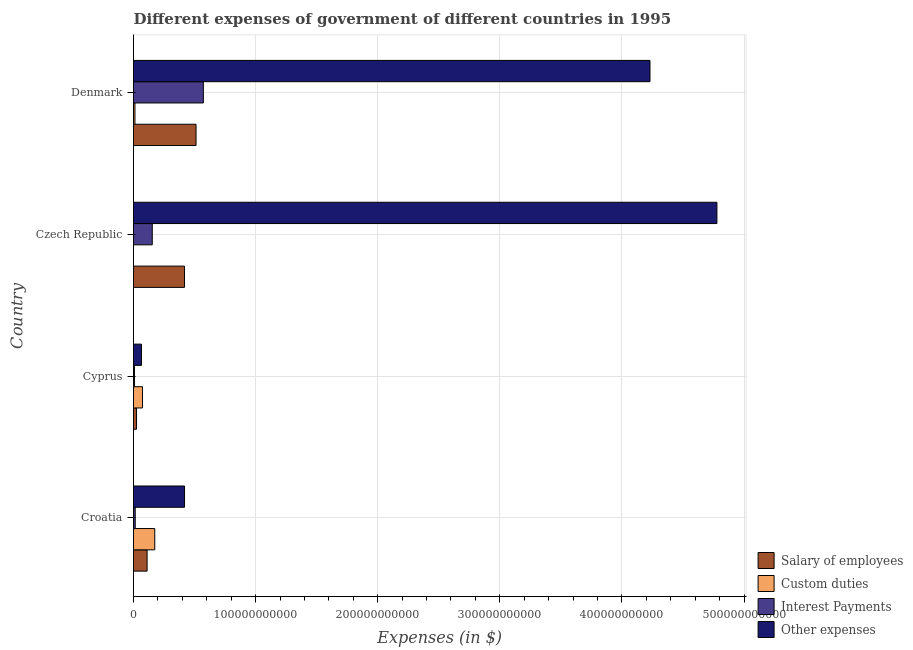How many different coloured bars are there?
Provide a short and direct response. 4. How many groups of bars are there?
Offer a very short reply. 4. Are the number of bars per tick equal to the number of legend labels?
Offer a very short reply. Yes. How many bars are there on the 3rd tick from the bottom?
Your response must be concise. 4. What is the label of the 3rd group of bars from the top?
Provide a short and direct response. Cyprus. What is the amount spent on interest payments in Denmark?
Give a very brief answer. 5.72e+1. Across all countries, what is the maximum amount spent on salary of employees?
Your answer should be compact. 5.12e+1. Across all countries, what is the minimum amount spent on salary of employees?
Make the answer very short. 2.48e+09. In which country was the amount spent on other expenses minimum?
Keep it short and to the point. Cyprus. What is the total amount spent on other expenses in the graph?
Provide a short and direct response. 9.49e+11. What is the difference between the amount spent on custom duties in Croatia and that in Czech Republic?
Give a very brief answer. 1.74e+1. What is the difference between the amount spent on salary of employees in Czech Republic and the amount spent on custom duties in Denmark?
Your answer should be compact. 4.06e+1. What is the average amount spent on custom duties per country?
Give a very brief answer. 6.49e+09. What is the difference between the amount spent on custom duties and amount spent on interest payments in Croatia?
Give a very brief answer. 1.60e+1. What is the ratio of the amount spent on interest payments in Croatia to that in Czech Republic?
Ensure brevity in your answer.  0.09. What is the difference between the highest and the second highest amount spent on interest payments?
Offer a very short reply. 4.18e+1. What is the difference between the highest and the lowest amount spent on custom duties?
Give a very brief answer. 1.74e+1. What does the 3rd bar from the top in Cyprus represents?
Provide a succinct answer. Custom duties. What does the 2nd bar from the bottom in Czech Republic represents?
Provide a short and direct response. Custom duties. How many bars are there?
Make the answer very short. 16. Are all the bars in the graph horizontal?
Provide a short and direct response. Yes. How many countries are there in the graph?
Provide a short and direct response. 4. What is the difference between two consecutive major ticks on the X-axis?
Your response must be concise. 1.00e+11. Are the values on the major ticks of X-axis written in scientific E-notation?
Offer a very short reply. No. Does the graph contain any zero values?
Provide a short and direct response. No. Does the graph contain grids?
Provide a short and direct response. Yes. How are the legend labels stacked?
Make the answer very short. Vertical. What is the title of the graph?
Provide a succinct answer. Different expenses of government of different countries in 1995. Does "Austria" appear as one of the legend labels in the graph?
Ensure brevity in your answer.  No. What is the label or title of the X-axis?
Provide a short and direct response. Expenses (in $). What is the Expenses (in $) of Salary of employees in Croatia?
Your answer should be compact. 1.11e+1. What is the Expenses (in $) in Custom duties in Croatia?
Offer a very short reply. 1.74e+1. What is the Expenses (in $) of Interest Payments in Croatia?
Your answer should be very brief. 1.40e+09. What is the Expenses (in $) of Other expenses in Croatia?
Keep it short and to the point. 4.18e+1. What is the Expenses (in $) of Salary of employees in Cyprus?
Your response must be concise. 2.48e+09. What is the Expenses (in $) of Custom duties in Cyprus?
Your answer should be very brief. 7.35e+09. What is the Expenses (in $) in Interest Payments in Cyprus?
Give a very brief answer. 7.72e+08. What is the Expenses (in $) in Other expenses in Cyprus?
Keep it short and to the point. 6.52e+09. What is the Expenses (in $) of Salary of employees in Czech Republic?
Give a very brief answer. 4.17e+1. What is the Expenses (in $) in Custom duties in Czech Republic?
Provide a short and direct response. 5.00e+05. What is the Expenses (in $) of Interest Payments in Czech Republic?
Provide a succinct answer. 1.54e+1. What is the Expenses (in $) of Other expenses in Czech Republic?
Give a very brief answer. 4.78e+11. What is the Expenses (in $) in Salary of employees in Denmark?
Ensure brevity in your answer.  5.12e+1. What is the Expenses (in $) of Custom duties in Denmark?
Offer a very short reply. 1.18e+09. What is the Expenses (in $) of Interest Payments in Denmark?
Keep it short and to the point. 5.72e+1. What is the Expenses (in $) in Other expenses in Denmark?
Give a very brief answer. 4.23e+11. Across all countries, what is the maximum Expenses (in $) of Salary of employees?
Your answer should be compact. 5.12e+1. Across all countries, what is the maximum Expenses (in $) in Custom duties?
Your answer should be compact. 1.74e+1. Across all countries, what is the maximum Expenses (in $) in Interest Payments?
Your response must be concise. 5.72e+1. Across all countries, what is the maximum Expenses (in $) of Other expenses?
Give a very brief answer. 4.78e+11. Across all countries, what is the minimum Expenses (in $) of Salary of employees?
Offer a very short reply. 2.48e+09. Across all countries, what is the minimum Expenses (in $) in Custom duties?
Offer a very short reply. 5.00e+05. Across all countries, what is the minimum Expenses (in $) in Interest Payments?
Give a very brief answer. 7.72e+08. Across all countries, what is the minimum Expenses (in $) of Other expenses?
Provide a short and direct response. 6.52e+09. What is the total Expenses (in $) of Salary of employees in the graph?
Your answer should be compact. 1.07e+11. What is the total Expenses (in $) of Custom duties in the graph?
Ensure brevity in your answer.  2.59e+1. What is the total Expenses (in $) of Interest Payments in the graph?
Provide a short and direct response. 7.47e+1. What is the total Expenses (in $) in Other expenses in the graph?
Your answer should be compact. 9.49e+11. What is the difference between the Expenses (in $) of Salary of employees in Croatia and that in Cyprus?
Offer a very short reply. 8.64e+09. What is the difference between the Expenses (in $) of Custom duties in Croatia and that in Cyprus?
Your response must be concise. 1.01e+1. What is the difference between the Expenses (in $) in Interest Payments in Croatia and that in Cyprus?
Offer a terse response. 6.28e+08. What is the difference between the Expenses (in $) in Other expenses in Croatia and that in Cyprus?
Keep it short and to the point. 3.53e+1. What is the difference between the Expenses (in $) in Salary of employees in Croatia and that in Czech Republic?
Your answer should be compact. -3.06e+1. What is the difference between the Expenses (in $) in Custom duties in Croatia and that in Czech Republic?
Keep it short and to the point. 1.74e+1. What is the difference between the Expenses (in $) in Interest Payments in Croatia and that in Czech Republic?
Keep it short and to the point. -1.40e+1. What is the difference between the Expenses (in $) in Other expenses in Croatia and that in Czech Republic?
Your answer should be compact. -4.36e+11. What is the difference between the Expenses (in $) in Salary of employees in Croatia and that in Denmark?
Make the answer very short. -4.01e+1. What is the difference between the Expenses (in $) of Custom duties in Croatia and that in Denmark?
Your response must be concise. 1.62e+1. What is the difference between the Expenses (in $) of Interest Payments in Croatia and that in Denmark?
Your response must be concise. -5.58e+1. What is the difference between the Expenses (in $) of Other expenses in Croatia and that in Denmark?
Your answer should be compact. -3.81e+11. What is the difference between the Expenses (in $) in Salary of employees in Cyprus and that in Czech Republic?
Offer a terse response. -3.93e+1. What is the difference between the Expenses (in $) in Custom duties in Cyprus and that in Czech Republic?
Give a very brief answer. 7.35e+09. What is the difference between the Expenses (in $) in Interest Payments in Cyprus and that in Czech Republic?
Offer a very short reply. -1.46e+1. What is the difference between the Expenses (in $) of Other expenses in Cyprus and that in Czech Republic?
Give a very brief answer. -4.71e+11. What is the difference between the Expenses (in $) in Salary of employees in Cyprus and that in Denmark?
Provide a succinct answer. -4.87e+1. What is the difference between the Expenses (in $) in Custom duties in Cyprus and that in Denmark?
Your answer should be very brief. 6.17e+09. What is the difference between the Expenses (in $) in Interest Payments in Cyprus and that in Denmark?
Provide a short and direct response. -5.64e+1. What is the difference between the Expenses (in $) in Other expenses in Cyprus and that in Denmark?
Your answer should be compact. -4.16e+11. What is the difference between the Expenses (in $) of Salary of employees in Czech Republic and that in Denmark?
Provide a short and direct response. -9.46e+09. What is the difference between the Expenses (in $) in Custom duties in Czech Republic and that in Denmark?
Your response must be concise. -1.18e+09. What is the difference between the Expenses (in $) of Interest Payments in Czech Republic and that in Denmark?
Provide a short and direct response. -4.18e+1. What is the difference between the Expenses (in $) of Other expenses in Czech Republic and that in Denmark?
Give a very brief answer. 5.48e+1. What is the difference between the Expenses (in $) in Salary of employees in Croatia and the Expenses (in $) in Custom duties in Cyprus?
Ensure brevity in your answer.  3.77e+09. What is the difference between the Expenses (in $) in Salary of employees in Croatia and the Expenses (in $) in Interest Payments in Cyprus?
Provide a short and direct response. 1.03e+1. What is the difference between the Expenses (in $) of Salary of employees in Croatia and the Expenses (in $) of Other expenses in Cyprus?
Your response must be concise. 4.60e+09. What is the difference between the Expenses (in $) of Custom duties in Croatia and the Expenses (in $) of Interest Payments in Cyprus?
Your answer should be compact. 1.66e+1. What is the difference between the Expenses (in $) in Custom duties in Croatia and the Expenses (in $) in Other expenses in Cyprus?
Keep it short and to the point. 1.09e+1. What is the difference between the Expenses (in $) of Interest Payments in Croatia and the Expenses (in $) of Other expenses in Cyprus?
Provide a short and direct response. -5.12e+09. What is the difference between the Expenses (in $) of Salary of employees in Croatia and the Expenses (in $) of Custom duties in Czech Republic?
Ensure brevity in your answer.  1.11e+1. What is the difference between the Expenses (in $) of Salary of employees in Croatia and the Expenses (in $) of Interest Payments in Czech Republic?
Keep it short and to the point. -4.24e+09. What is the difference between the Expenses (in $) of Salary of employees in Croatia and the Expenses (in $) of Other expenses in Czech Republic?
Your answer should be compact. -4.67e+11. What is the difference between the Expenses (in $) of Custom duties in Croatia and the Expenses (in $) of Interest Payments in Czech Republic?
Your answer should be very brief. 2.04e+09. What is the difference between the Expenses (in $) in Custom duties in Croatia and the Expenses (in $) in Other expenses in Czech Republic?
Your answer should be very brief. -4.60e+11. What is the difference between the Expenses (in $) of Interest Payments in Croatia and the Expenses (in $) of Other expenses in Czech Republic?
Keep it short and to the point. -4.76e+11. What is the difference between the Expenses (in $) in Salary of employees in Croatia and the Expenses (in $) in Custom duties in Denmark?
Provide a succinct answer. 9.94e+09. What is the difference between the Expenses (in $) of Salary of employees in Croatia and the Expenses (in $) of Interest Payments in Denmark?
Offer a terse response. -4.61e+1. What is the difference between the Expenses (in $) in Salary of employees in Croatia and the Expenses (in $) in Other expenses in Denmark?
Provide a short and direct response. -4.12e+11. What is the difference between the Expenses (in $) in Custom duties in Croatia and the Expenses (in $) in Interest Payments in Denmark?
Your answer should be very brief. -3.98e+1. What is the difference between the Expenses (in $) in Custom duties in Croatia and the Expenses (in $) in Other expenses in Denmark?
Make the answer very short. -4.06e+11. What is the difference between the Expenses (in $) in Interest Payments in Croatia and the Expenses (in $) in Other expenses in Denmark?
Your response must be concise. -4.22e+11. What is the difference between the Expenses (in $) in Salary of employees in Cyprus and the Expenses (in $) in Custom duties in Czech Republic?
Offer a terse response. 2.48e+09. What is the difference between the Expenses (in $) of Salary of employees in Cyprus and the Expenses (in $) of Interest Payments in Czech Republic?
Provide a short and direct response. -1.29e+1. What is the difference between the Expenses (in $) in Salary of employees in Cyprus and the Expenses (in $) in Other expenses in Czech Republic?
Ensure brevity in your answer.  -4.75e+11. What is the difference between the Expenses (in $) of Custom duties in Cyprus and the Expenses (in $) of Interest Payments in Czech Republic?
Make the answer very short. -8.01e+09. What is the difference between the Expenses (in $) of Custom duties in Cyprus and the Expenses (in $) of Other expenses in Czech Republic?
Your answer should be very brief. -4.70e+11. What is the difference between the Expenses (in $) of Interest Payments in Cyprus and the Expenses (in $) of Other expenses in Czech Republic?
Provide a short and direct response. -4.77e+11. What is the difference between the Expenses (in $) in Salary of employees in Cyprus and the Expenses (in $) in Custom duties in Denmark?
Your response must be concise. 1.30e+09. What is the difference between the Expenses (in $) in Salary of employees in Cyprus and the Expenses (in $) in Interest Payments in Denmark?
Your answer should be compact. -5.47e+1. What is the difference between the Expenses (in $) in Salary of employees in Cyprus and the Expenses (in $) in Other expenses in Denmark?
Your response must be concise. -4.20e+11. What is the difference between the Expenses (in $) of Custom duties in Cyprus and the Expenses (in $) of Interest Payments in Denmark?
Make the answer very short. -4.98e+1. What is the difference between the Expenses (in $) of Custom duties in Cyprus and the Expenses (in $) of Other expenses in Denmark?
Provide a short and direct response. -4.16e+11. What is the difference between the Expenses (in $) of Interest Payments in Cyprus and the Expenses (in $) of Other expenses in Denmark?
Your answer should be very brief. -4.22e+11. What is the difference between the Expenses (in $) in Salary of employees in Czech Republic and the Expenses (in $) in Custom duties in Denmark?
Provide a succinct answer. 4.06e+1. What is the difference between the Expenses (in $) in Salary of employees in Czech Republic and the Expenses (in $) in Interest Payments in Denmark?
Give a very brief answer. -1.55e+1. What is the difference between the Expenses (in $) of Salary of employees in Czech Republic and the Expenses (in $) of Other expenses in Denmark?
Your answer should be very brief. -3.81e+11. What is the difference between the Expenses (in $) of Custom duties in Czech Republic and the Expenses (in $) of Interest Payments in Denmark?
Give a very brief answer. -5.72e+1. What is the difference between the Expenses (in $) of Custom duties in Czech Republic and the Expenses (in $) of Other expenses in Denmark?
Your answer should be compact. -4.23e+11. What is the difference between the Expenses (in $) of Interest Payments in Czech Republic and the Expenses (in $) of Other expenses in Denmark?
Your response must be concise. -4.08e+11. What is the average Expenses (in $) of Salary of employees per country?
Provide a succinct answer. 2.66e+1. What is the average Expenses (in $) in Custom duties per country?
Offer a very short reply. 6.49e+09. What is the average Expenses (in $) of Interest Payments per country?
Ensure brevity in your answer.  1.87e+1. What is the average Expenses (in $) in Other expenses per country?
Ensure brevity in your answer.  2.37e+11. What is the difference between the Expenses (in $) of Salary of employees and Expenses (in $) of Custom duties in Croatia?
Offer a very short reply. -6.29e+09. What is the difference between the Expenses (in $) in Salary of employees and Expenses (in $) in Interest Payments in Croatia?
Offer a very short reply. 9.72e+09. What is the difference between the Expenses (in $) in Salary of employees and Expenses (in $) in Other expenses in Croatia?
Offer a very short reply. -3.07e+1. What is the difference between the Expenses (in $) of Custom duties and Expenses (in $) of Interest Payments in Croatia?
Your response must be concise. 1.60e+1. What is the difference between the Expenses (in $) in Custom duties and Expenses (in $) in Other expenses in Croatia?
Ensure brevity in your answer.  -2.44e+1. What is the difference between the Expenses (in $) of Interest Payments and Expenses (in $) of Other expenses in Croatia?
Keep it short and to the point. -4.04e+1. What is the difference between the Expenses (in $) in Salary of employees and Expenses (in $) in Custom duties in Cyprus?
Provide a short and direct response. -4.87e+09. What is the difference between the Expenses (in $) of Salary of employees and Expenses (in $) of Interest Payments in Cyprus?
Give a very brief answer. 1.71e+09. What is the difference between the Expenses (in $) of Salary of employees and Expenses (in $) of Other expenses in Cyprus?
Your response must be concise. -4.04e+09. What is the difference between the Expenses (in $) in Custom duties and Expenses (in $) in Interest Payments in Cyprus?
Make the answer very short. 6.58e+09. What is the difference between the Expenses (in $) in Custom duties and Expenses (in $) in Other expenses in Cyprus?
Provide a succinct answer. 8.31e+08. What is the difference between the Expenses (in $) of Interest Payments and Expenses (in $) of Other expenses in Cyprus?
Provide a succinct answer. -5.75e+09. What is the difference between the Expenses (in $) in Salary of employees and Expenses (in $) in Custom duties in Czech Republic?
Your answer should be very brief. 4.17e+1. What is the difference between the Expenses (in $) of Salary of employees and Expenses (in $) of Interest Payments in Czech Republic?
Provide a short and direct response. 2.64e+1. What is the difference between the Expenses (in $) of Salary of employees and Expenses (in $) of Other expenses in Czech Republic?
Ensure brevity in your answer.  -4.36e+11. What is the difference between the Expenses (in $) in Custom duties and Expenses (in $) in Interest Payments in Czech Republic?
Keep it short and to the point. -1.54e+1. What is the difference between the Expenses (in $) of Custom duties and Expenses (in $) of Other expenses in Czech Republic?
Give a very brief answer. -4.78e+11. What is the difference between the Expenses (in $) of Interest Payments and Expenses (in $) of Other expenses in Czech Republic?
Your answer should be very brief. -4.62e+11. What is the difference between the Expenses (in $) of Salary of employees and Expenses (in $) of Custom duties in Denmark?
Provide a succinct answer. 5.00e+1. What is the difference between the Expenses (in $) of Salary of employees and Expenses (in $) of Interest Payments in Denmark?
Keep it short and to the point. -5.99e+09. What is the difference between the Expenses (in $) in Salary of employees and Expenses (in $) in Other expenses in Denmark?
Your answer should be very brief. -3.72e+11. What is the difference between the Expenses (in $) of Custom duties and Expenses (in $) of Interest Payments in Denmark?
Give a very brief answer. -5.60e+1. What is the difference between the Expenses (in $) of Custom duties and Expenses (in $) of Other expenses in Denmark?
Your answer should be compact. -4.22e+11. What is the difference between the Expenses (in $) of Interest Payments and Expenses (in $) of Other expenses in Denmark?
Your answer should be compact. -3.66e+11. What is the ratio of the Expenses (in $) in Salary of employees in Croatia to that in Cyprus?
Your response must be concise. 4.48. What is the ratio of the Expenses (in $) of Custom duties in Croatia to that in Cyprus?
Ensure brevity in your answer.  2.37. What is the ratio of the Expenses (in $) of Interest Payments in Croatia to that in Cyprus?
Your answer should be very brief. 1.81. What is the ratio of the Expenses (in $) in Other expenses in Croatia to that in Cyprus?
Your answer should be compact. 6.41. What is the ratio of the Expenses (in $) in Salary of employees in Croatia to that in Czech Republic?
Make the answer very short. 0.27. What is the ratio of the Expenses (in $) of Custom duties in Croatia to that in Czech Republic?
Provide a short and direct response. 3.48e+04. What is the ratio of the Expenses (in $) of Interest Payments in Croatia to that in Czech Republic?
Your answer should be compact. 0.09. What is the ratio of the Expenses (in $) in Other expenses in Croatia to that in Czech Republic?
Your response must be concise. 0.09. What is the ratio of the Expenses (in $) in Salary of employees in Croatia to that in Denmark?
Ensure brevity in your answer.  0.22. What is the ratio of the Expenses (in $) in Custom duties in Croatia to that in Denmark?
Offer a very short reply. 14.76. What is the ratio of the Expenses (in $) in Interest Payments in Croatia to that in Denmark?
Offer a terse response. 0.02. What is the ratio of the Expenses (in $) of Other expenses in Croatia to that in Denmark?
Ensure brevity in your answer.  0.1. What is the ratio of the Expenses (in $) in Salary of employees in Cyprus to that in Czech Republic?
Ensure brevity in your answer.  0.06. What is the ratio of the Expenses (in $) in Custom duties in Cyprus to that in Czech Republic?
Give a very brief answer. 1.47e+04. What is the ratio of the Expenses (in $) of Interest Payments in Cyprus to that in Czech Republic?
Give a very brief answer. 0.05. What is the ratio of the Expenses (in $) of Other expenses in Cyprus to that in Czech Republic?
Your answer should be compact. 0.01. What is the ratio of the Expenses (in $) of Salary of employees in Cyprus to that in Denmark?
Your answer should be compact. 0.05. What is the ratio of the Expenses (in $) in Custom duties in Cyprus to that in Denmark?
Your answer should be compact. 6.23. What is the ratio of the Expenses (in $) in Interest Payments in Cyprus to that in Denmark?
Keep it short and to the point. 0.01. What is the ratio of the Expenses (in $) of Other expenses in Cyprus to that in Denmark?
Provide a succinct answer. 0.02. What is the ratio of the Expenses (in $) in Salary of employees in Czech Republic to that in Denmark?
Your answer should be compact. 0.82. What is the ratio of the Expenses (in $) of Interest Payments in Czech Republic to that in Denmark?
Offer a terse response. 0.27. What is the ratio of the Expenses (in $) of Other expenses in Czech Republic to that in Denmark?
Your answer should be very brief. 1.13. What is the difference between the highest and the second highest Expenses (in $) of Salary of employees?
Provide a short and direct response. 9.46e+09. What is the difference between the highest and the second highest Expenses (in $) of Custom duties?
Your answer should be compact. 1.01e+1. What is the difference between the highest and the second highest Expenses (in $) in Interest Payments?
Ensure brevity in your answer.  4.18e+1. What is the difference between the highest and the second highest Expenses (in $) of Other expenses?
Your response must be concise. 5.48e+1. What is the difference between the highest and the lowest Expenses (in $) of Salary of employees?
Offer a terse response. 4.87e+1. What is the difference between the highest and the lowest Expenses (in $) in Custom duties?
Keep it short and to the point. 1.74e+1. What is the difference between the highest and the lowest Expenses (in $) of Interest Payments?
Your answer should be very brief. 5.64e+1. What is the difference between the highest and the lowest Expenses (in $) of Other expenses?
Provide a succinct answer. 4.71e+11. 